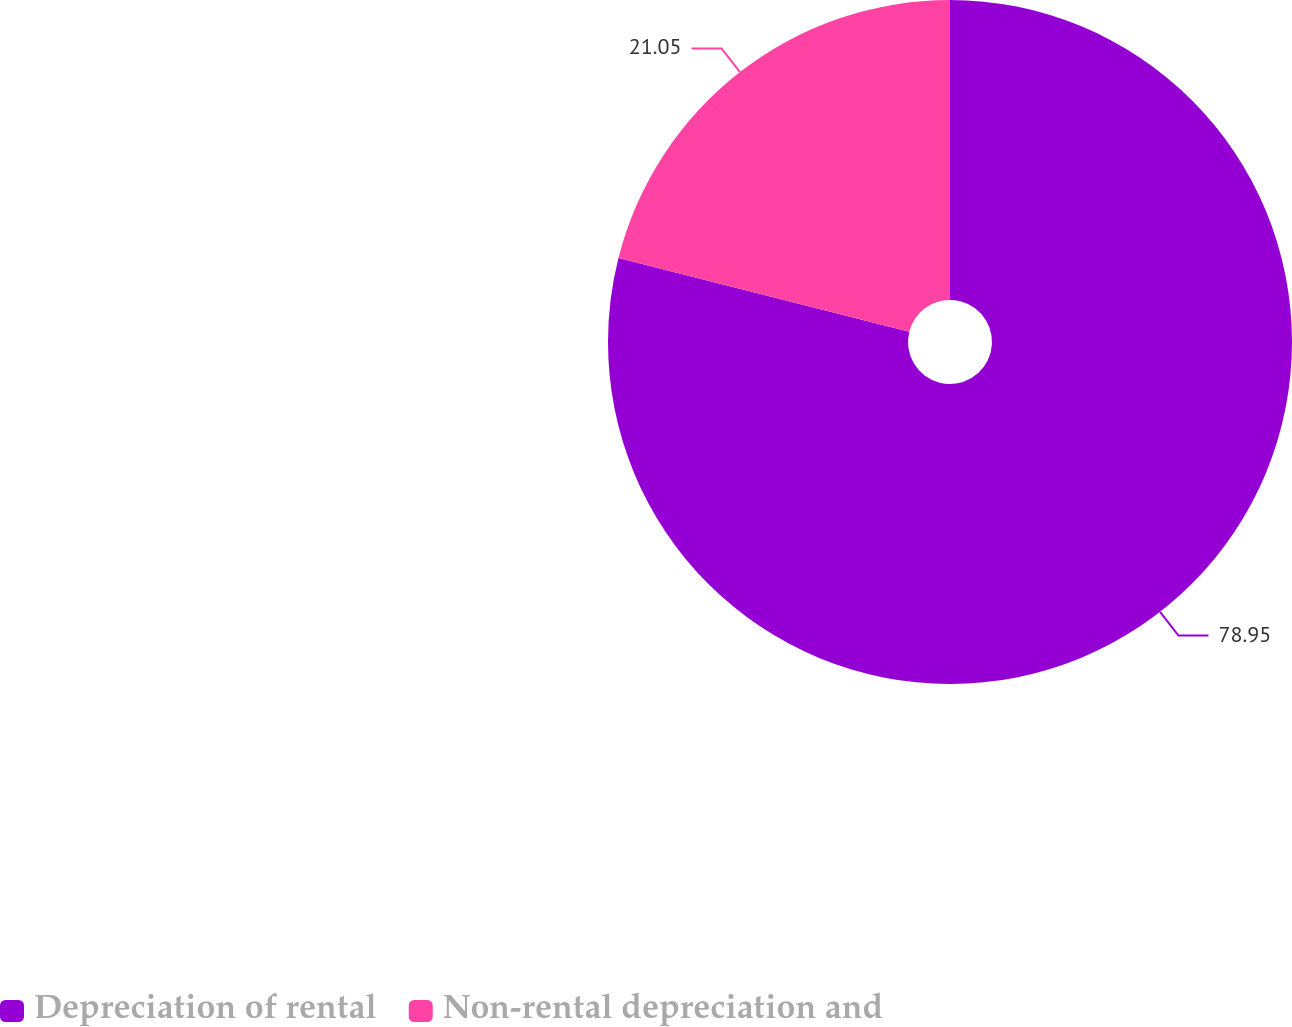Convert chart. <chart><loc_0><loc_0><loc_500><loc_500><pie_chart><fcel>Depreciation of rental<fcel>Non-rental depreciation and<nl><fcel>78.95%<fcel>21.05%<nl></chart> 